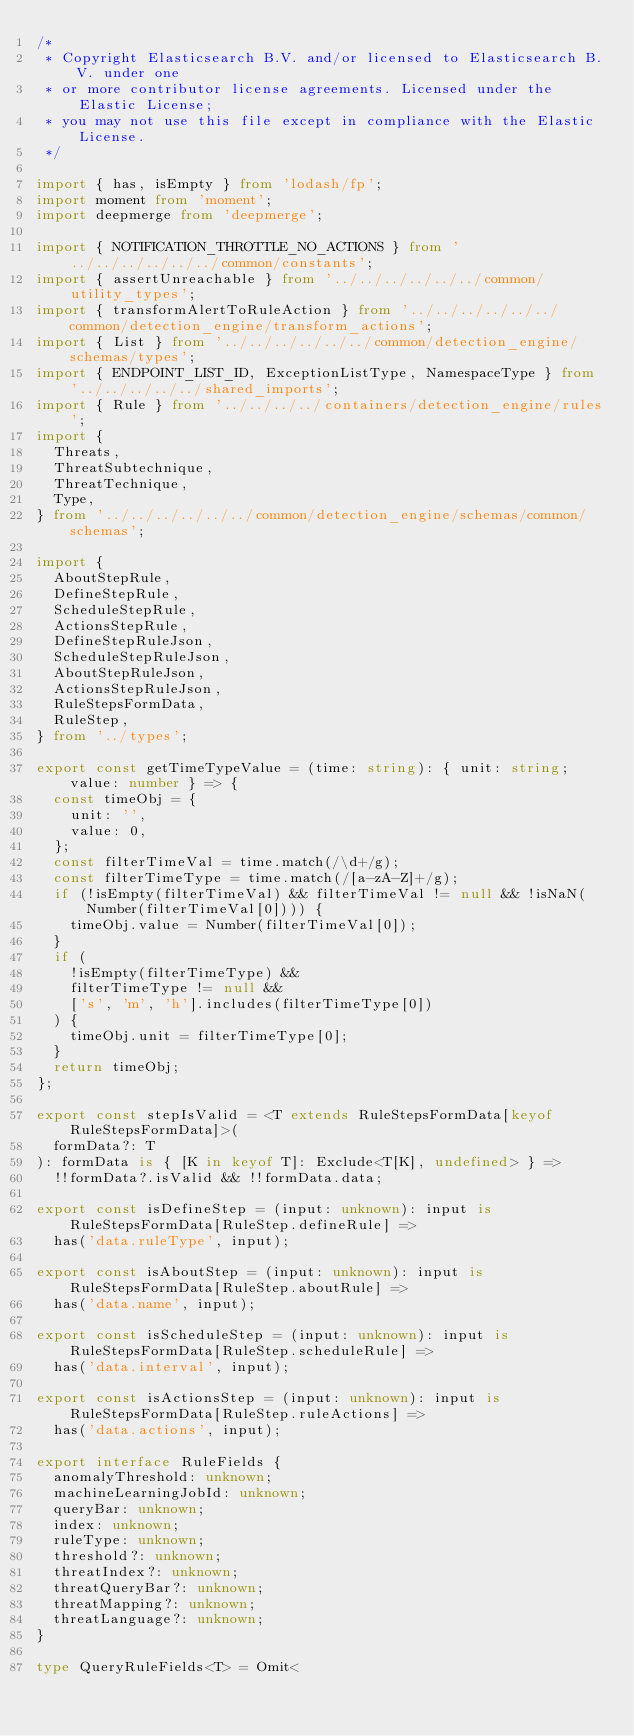<code> <loc_0><loc_0><loc_500><loc_500><_TypeScript_>/*
 * Copyright Elasticsearch B.V. and/or licensed to Elasticsearch B.V. under one
 * or more contributor license agreements. Licensed under the Elastic License;
 * you may not use this file except in compliance with the Elastic License.
 */

import { has, isEmpty } from 'lodash/fp';
import moment from 'moment';
import deepmerge from 'deepmerge';

import { NOTIFICATION_THROTTLE_NO_ACTIONS } from '../../../../../../common/constants';
import { assertUnreachable } from '../../../../../../common/utility_types';
import { transformAlertToRuleAction } from '../../../../../../common/detection_engine/transform_actions';
import { List } from '../../../../../../common/detection_engine/schemas/types';
import { ENDPOINT_LIST_ID, ExceptionListType, NamespaceType } from '../../../../../shared_imports';
import { Rule } from '../../../../containers/detection_engine/rules';
import {
  Threats,
  ThreatSubtechnique,
  ThreatTechnique,
  Type,
} from '../../../../../../common/detection_engine/schemas/common/schemas';

import {
  AboutStepRule,
  DefineStepRule,
  ScheduleStepRule,
  ActionsStepRule,
  DefineStepRuleJson,
  ScheduleStepRuleJson,
  AboutStepRuleJson,
  ActionsStepRuleJson,
  RuleStepsFormData,
  RuleStep,
} from '../types';

export const getTimeTypeValue = (time: string): { unit: string; value: number } => {
  const timeObj = {
    unit: '',
    value: 0,
  };
  const filterTimeVal = time.match(/\d+/g);
  const filterTimeType = time.match(/[a-zA-Z]+/g);
  if (!isEmpty(filterTimeVal) && filterTimeVal != null && !isNaN(Number(filterTimeVal[0]))) {
    timeObj.value = Number(filterTimeVal[0]);
  }
  if (
    !isEmpty(filterTimeType) &&
    filterTimeType != null &&
    ['s', 'm', 'h'].includes(filterTimeType[0])
  ) {
    timeObj.unit = filterTimeType[0];
  }
  return timeObj;
};

export const stepIsValid = <T extends RuleStepsFormData[keyof RuleStepsFormData]>(
  formData?: T
): formData is { [K in keyof T]: Exclude<T[K], undefined> } =>
  !!formData?.isValid && !!formData.data;

export const isDefineStep = (input: unknown): input is RuleStepsFormData[RuleStep.defineRule] =>
  has('data.ruleType', input);

export const isAboutStep = (input: unknown): input is RuleStepsFormData[RuleStep.aboutRule] =>
  has('data.name', input);

export const isScheduleStep = (input: unknown): input is RuleStepsFormData[RuleStep.scheduleRule] =>
  has('data.interval', input);

export const isActionsStep = (input: unknown): input is RuleStepsFormData[RuleStep.ruleActions] =>
  has('data.actions', input);

export interface RuleFields {
  anomalyThreshold: unknown;
  machineLearningJobId: unknown;
  queryBar: unknown;
  index: unknown;
  ruleType: unknown;
  threshold?: unknown;
  threatIndex?: unknown;
  threatQueryBar?: unknown;
  threatMapping?: unknown;
  threatLanguage?: unknown;
}

type QueryRuleFields<T> = Omit<</code> 